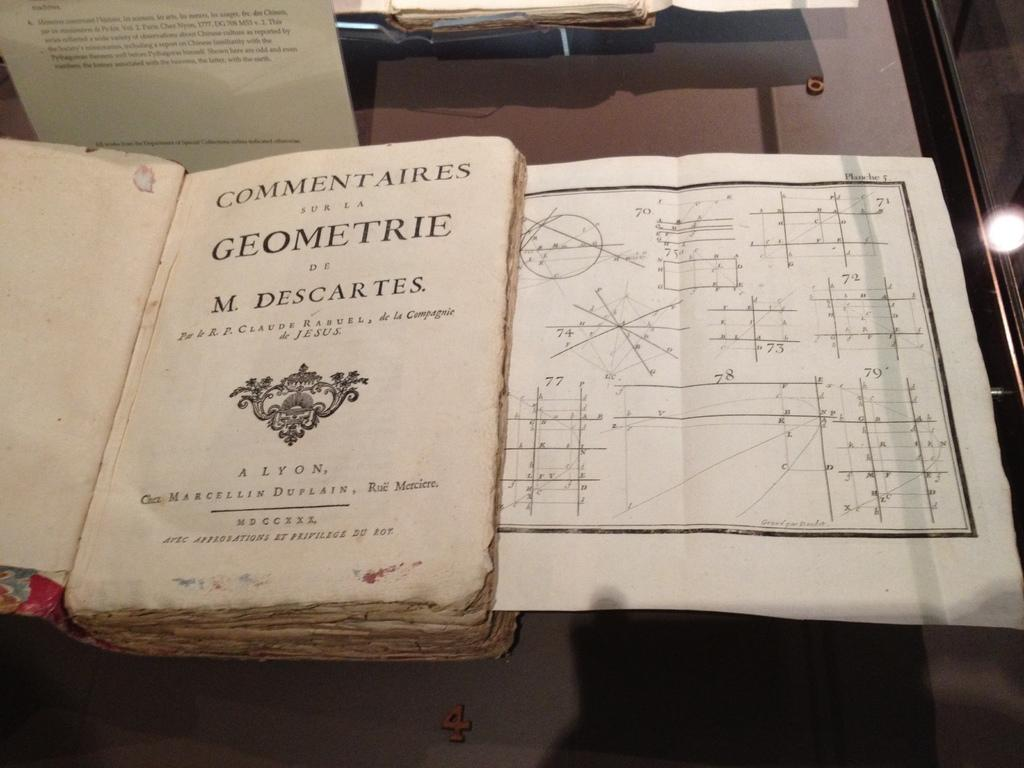Provide a one-sentence caption for the provided image. Open book that is about Commentaries sur la geomerie. 